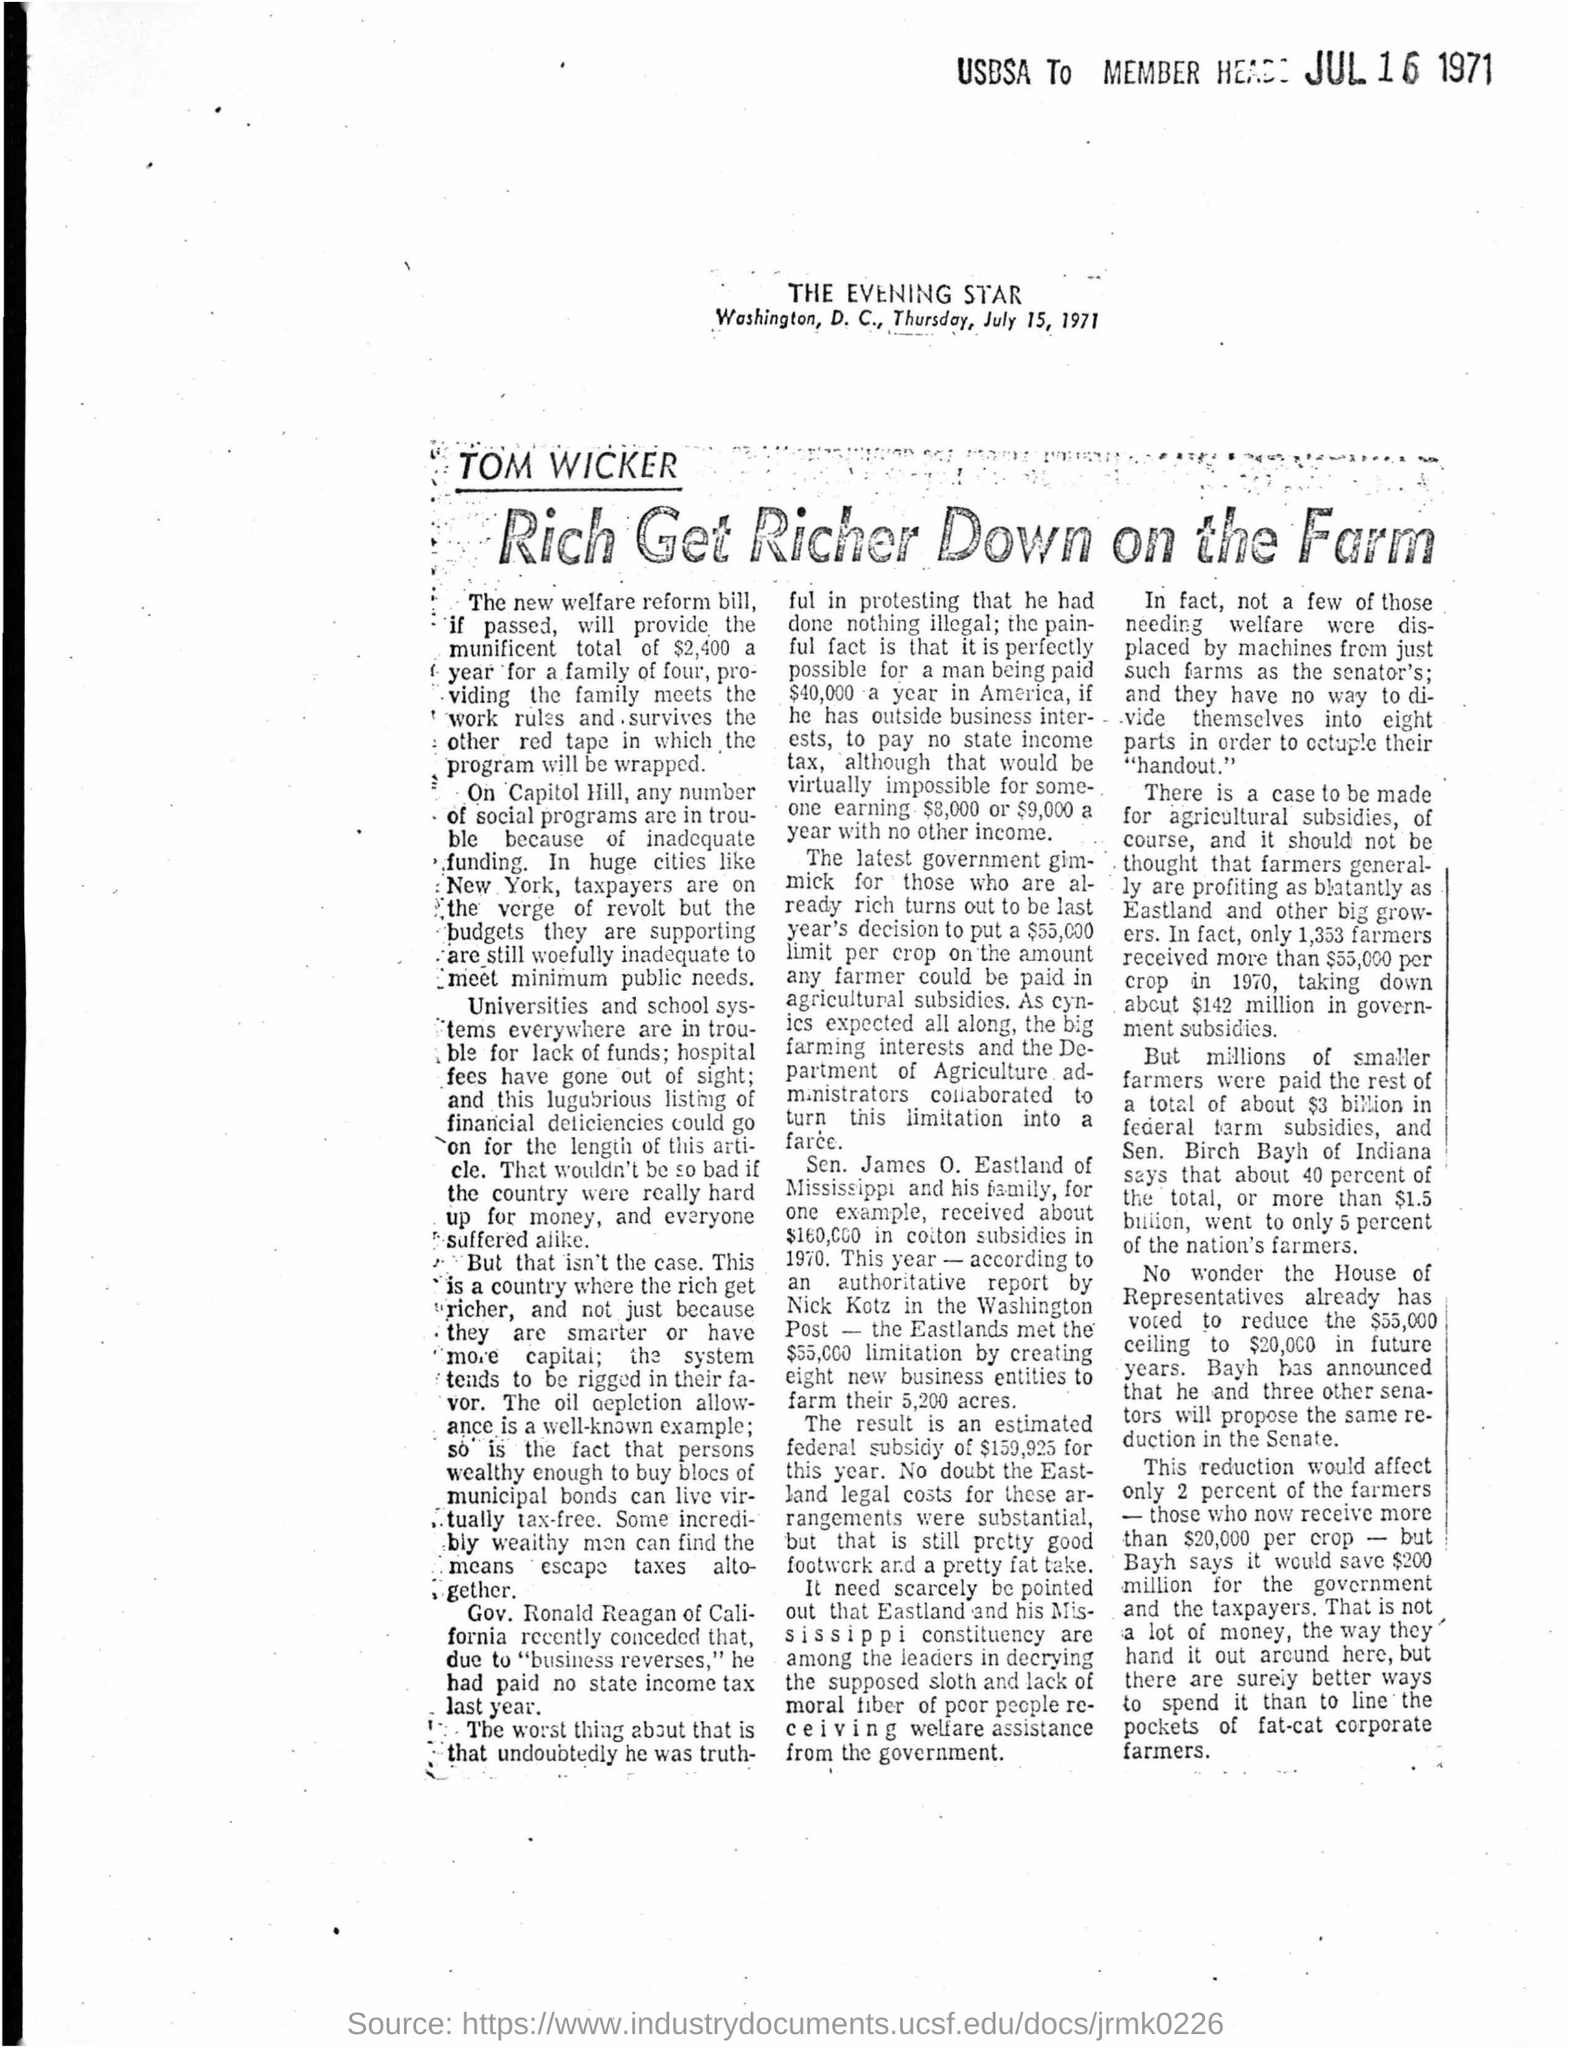Which newspaper printed this article?
Your response must be concise. THE EVENING STAR. When was it printed?
Your answer should be very brief. Thursday, July 15, 1971. 